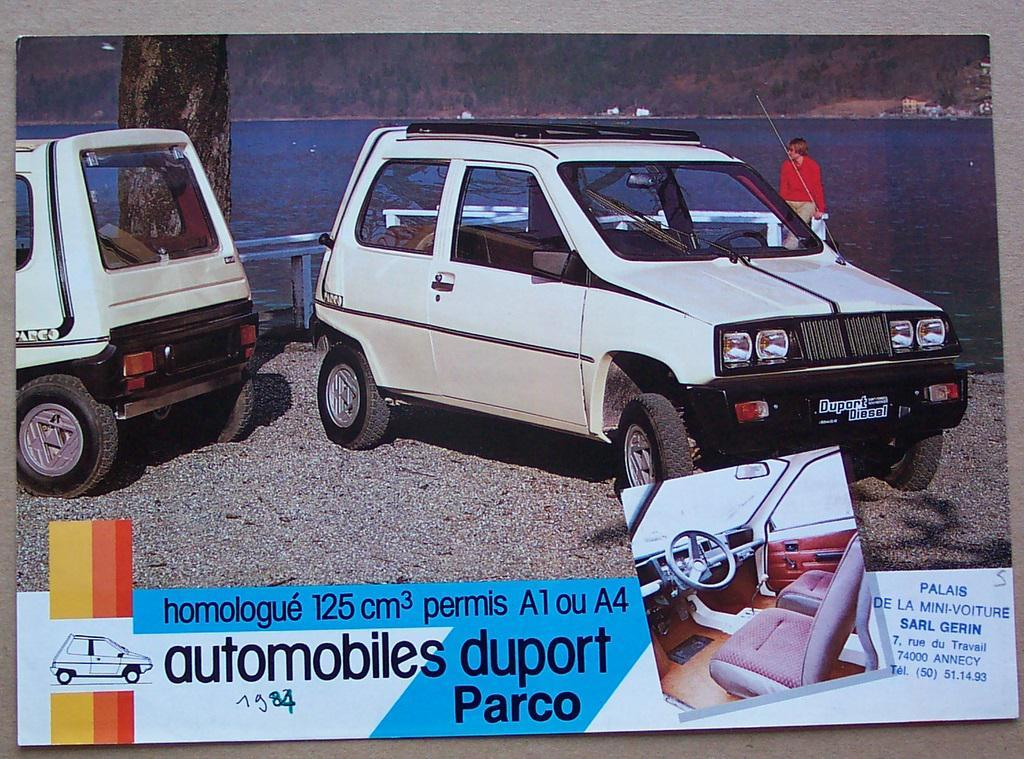How many vehicles can be seen in the image? There are two vehicles in the image. What can be seen near the vehicles? There is a railing in the image. What natural element is present in the image? There is a tree in the image. What type of landscape is visible in the image? There is water visible in the image. Is there a person present in the image? Yes, there is a person in the image. What is written in the front of the image? There is something written in the front of the image. What type of plantation can be seen in the image? There is no plantation present in the image. What is the visibility like in the image due to the fog? There is no fog present in the image, so visibility is not affected. 